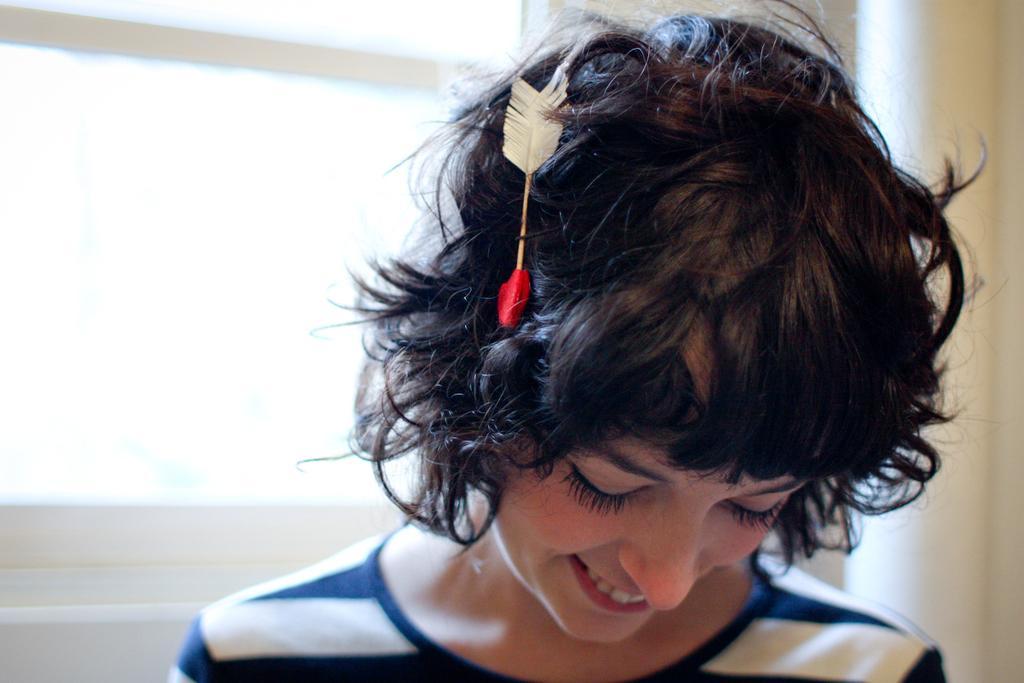Can you describe this image briefly? In this picture we can see a woman is smiling and on the woman head there is an object. Behind the woman there is a wall. 